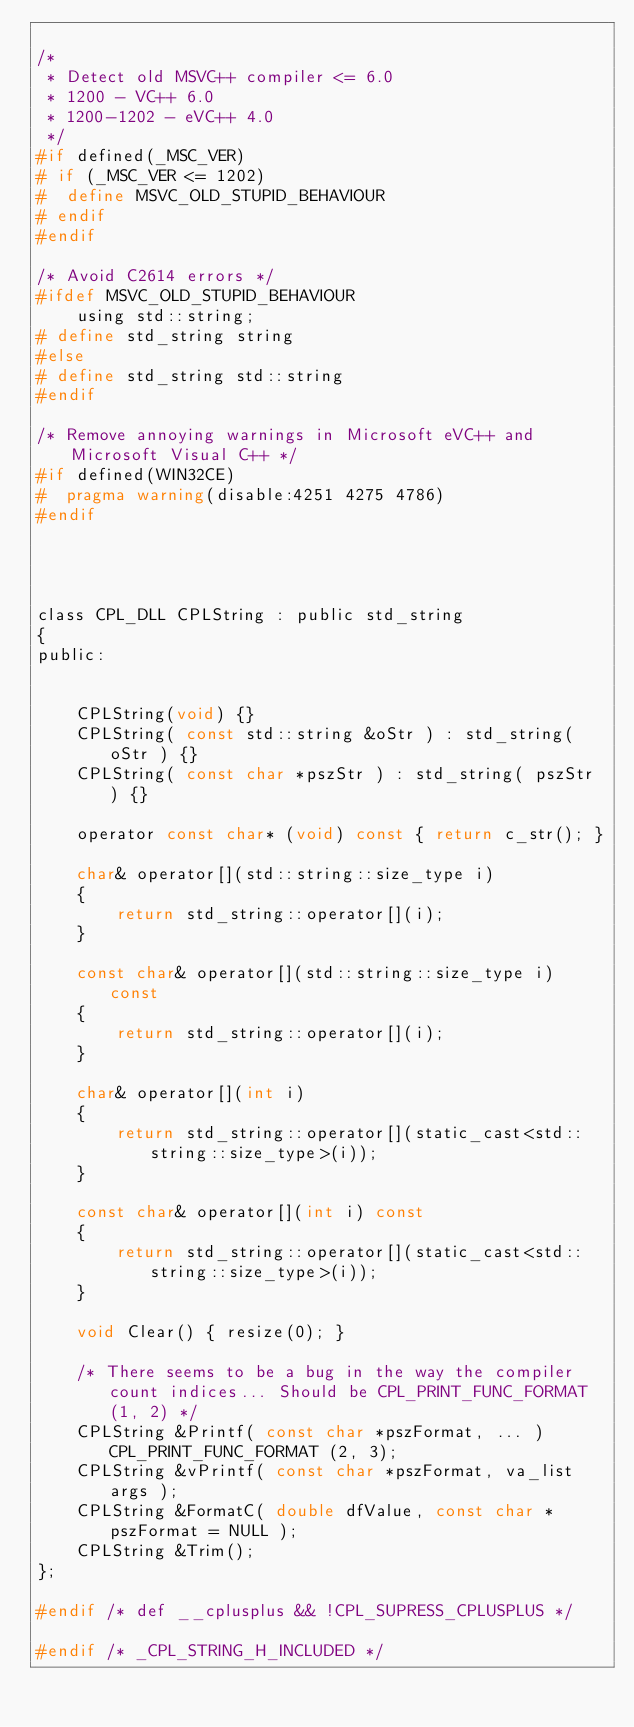Convert code to text. <code><loc_0><loc_0><loc_500><loc_500><_C_>
/*
 * Detect old MSVC++ compiler <= 6.0
 * 1200 - VC++ 6.0
 * 1200-1202 - eVC++ 4.0
 */
#if defined(_MSC_VER) 
# if (_MSC_VER <= 1202) 
#  define MSVC_OLD_STUPID_BEHAVIOUR 
# endif
#endif

/* Avoid C2614 errors */
#ifdef MSVC_OLD_STUPID_BEHAVIOUR
    using std::string;
# define std_string string
#else
# define std_string std::string
#endif 

/* Remove annoying warnings in Microsoft eVC++ and Microsoft Visual C++ */
#if defined(WIN32CE)
#  pragma warning(disable:4251 4275 4786)
#endif




class CPL_DLL CPLString : public std_string
{
public:

    
    CPLString(void) {}
    CPLString( const std::string &oStr ) : std_string( oStr ) {}
    CPLString( const char *pszStr ) : std_string( pszStr ) {}
    
    operator const char* (void) const { return c_str(); }

    char& operator[](std::string::size_type i)
    {
        return std_string::operator[](i);
    }
    
    const char& operator[](std::string::size_type i) const
    {
        return std_string::operator[](i);
    }

    char& operator[](int i)
    {
        return std_string::operator[](static_cast<std::string::size_type>(i));
    }

    const char& operator[](int i) const
    {
        return std_string::operator[](static_cast<std::string::size_type>(i));
    }

    void Clear() { resize(0); }

    /* There seems to be a bug in the way the compiler count indices... Should be CPL_PRINT_FUNC_FORMAT (1, 2) */
    CPLString &Printf( const char *pszFormat, ... ) CPL_PRINT_FUNC_FORMAT (2, 3);
    CPLString &vPrintf( const char *pszFormat, va_list args );
    CPLString &FormatC( double dfValue, const char *pszFormat = NULL );
    CPLString &Trim();
};

#endif /* def __cplusplus && !CPL_SUPRESS_CPLUSPLUS */

#endif /* _CPL_STRING_H_INCLUDED */
</code> 